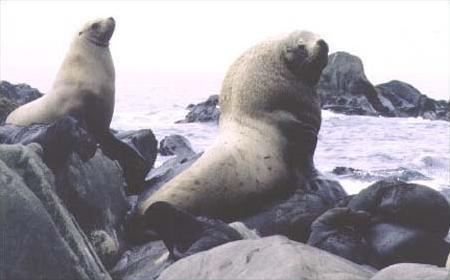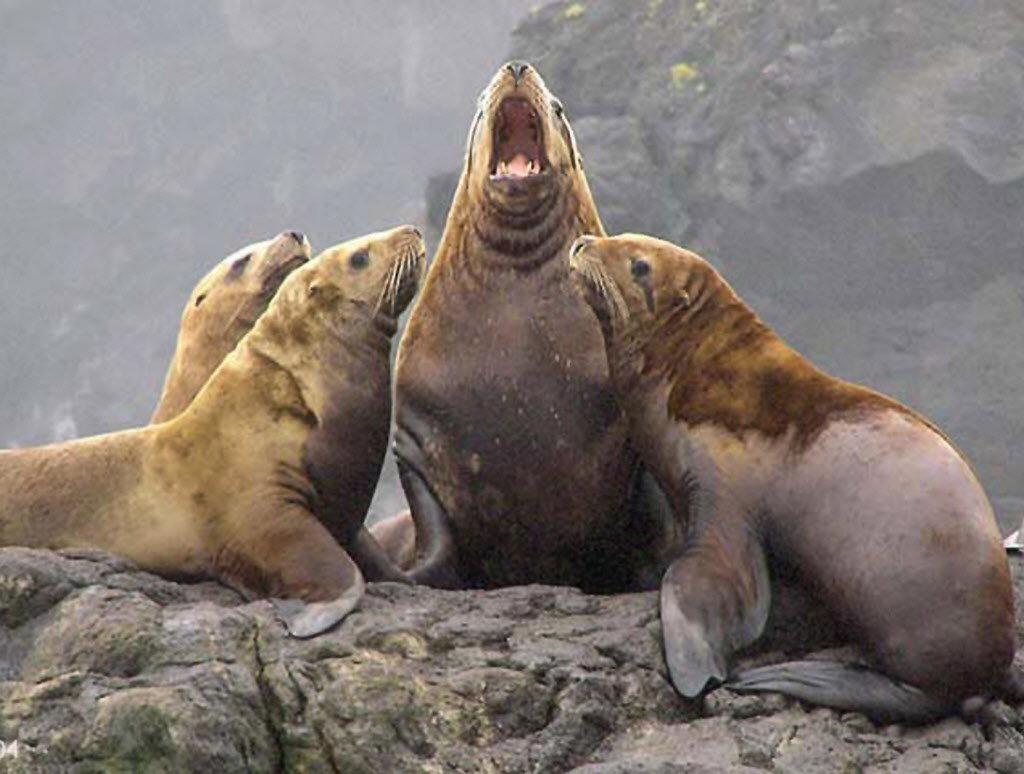The first image is the image on the left, the second image is the image on the right. Given the left and right images, does the statement "At least one of the images shows only one sea lion." hold true? Answer yes or no. No. The first image is the image on the left, the second image is the image on the right. For the images shown, is this caption "An image shows exactly one seal, with flippers on a surface in front of its body." true? Answer yes or no. No. 